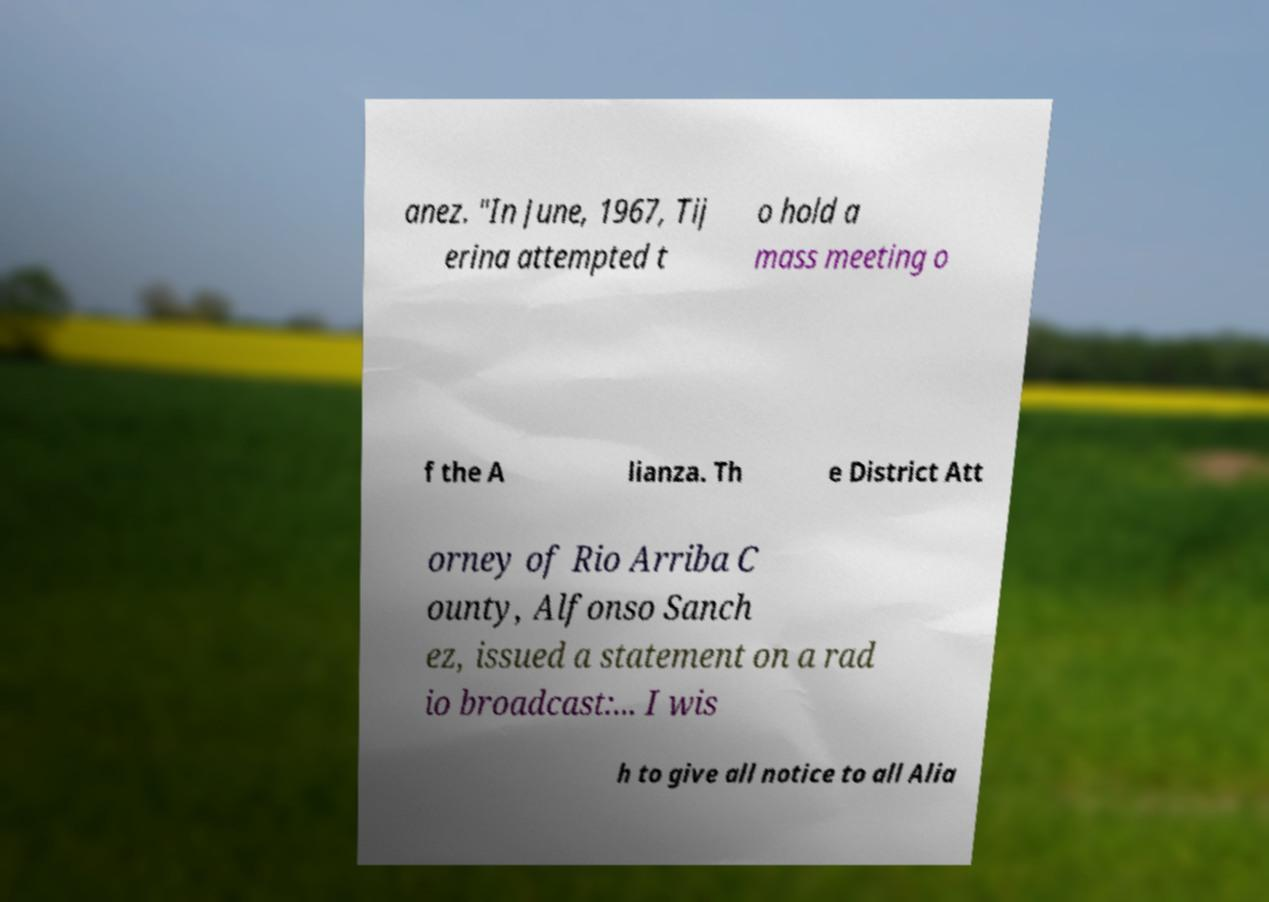Can you read and provide the text displayed in the image?This photo seems to have some interesting text. Can you extract and type it out for me? anez. "In June, 1967, Tij erina attempted t o hold a mass meeting o f the A lianza. Th e District Att orney of Rio Arriba C ounty, Alfonso Sanch ez, issued a statement on a rad io broadcast:... I wis h to give all notice to all Alia 